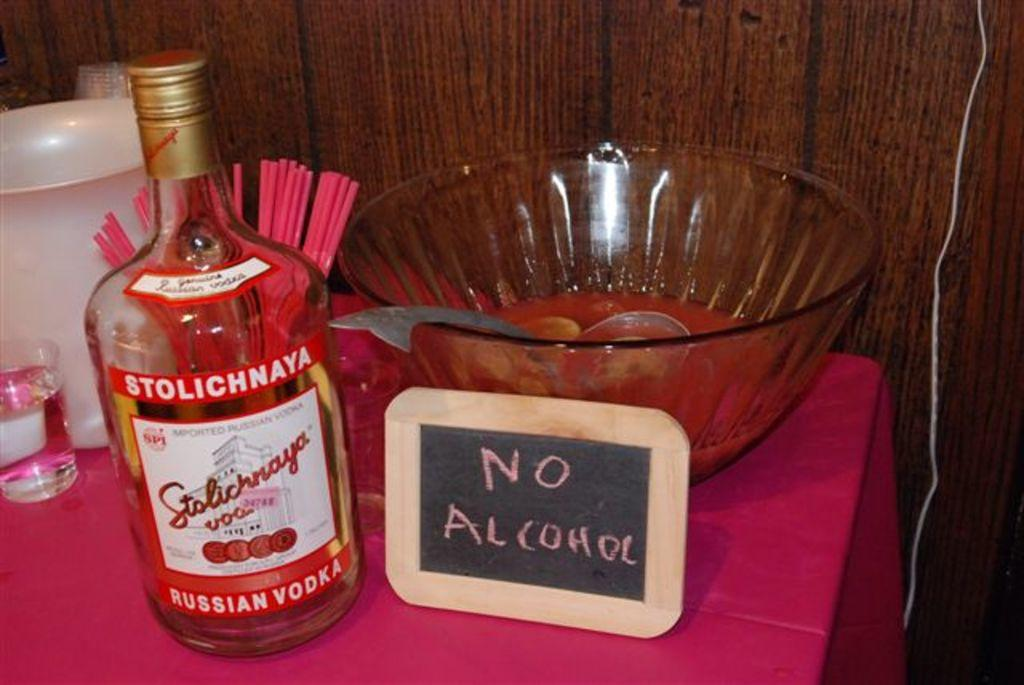<image>
Write a terse but informative summary of the picture. A bottle of Stolichnaya RUSSIAN VODKA next to a sign that says NO ALCOHOL. 